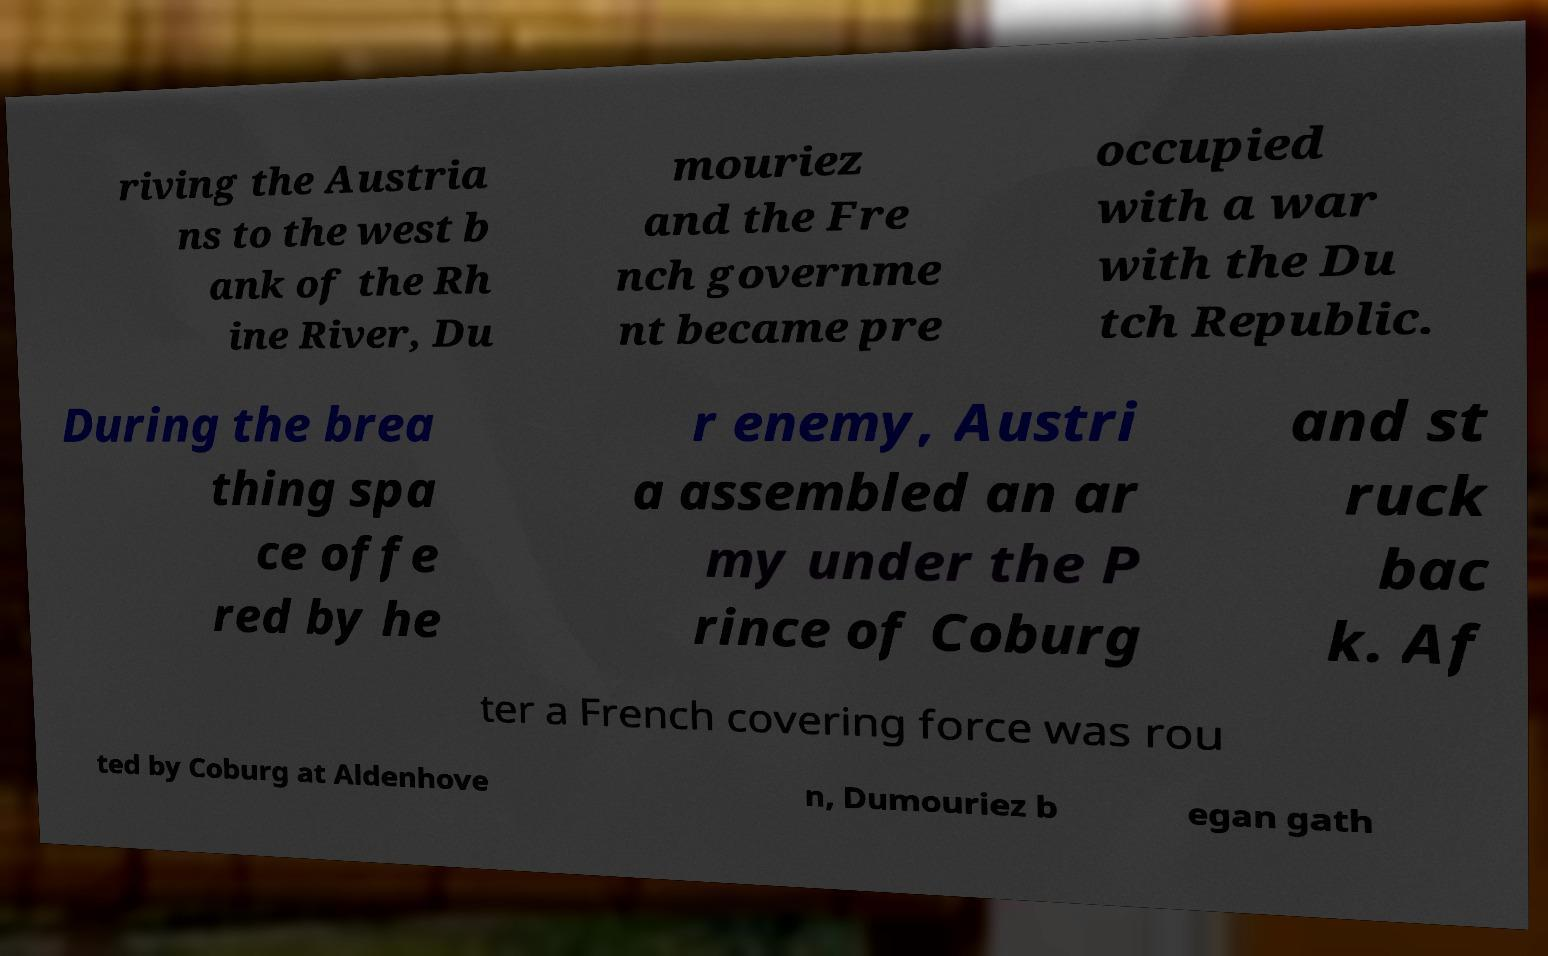There's text embedded in this image that I need extracted. Can you transcribe it verbatim? riving the Austria ns to the west b ank of the Rh ine River, Du mouriez and the Fre nch governme nt became pre occupied with a war with the Du tch Republic. During the brea thing spa ce offe red by he r enemy, Austri a assembled an ar my under the P rince of Coburg and st ruck bac k. Af ter a French covering force was rou ted by Coburg at Aldenhove n, Dumouriez b egan gath 